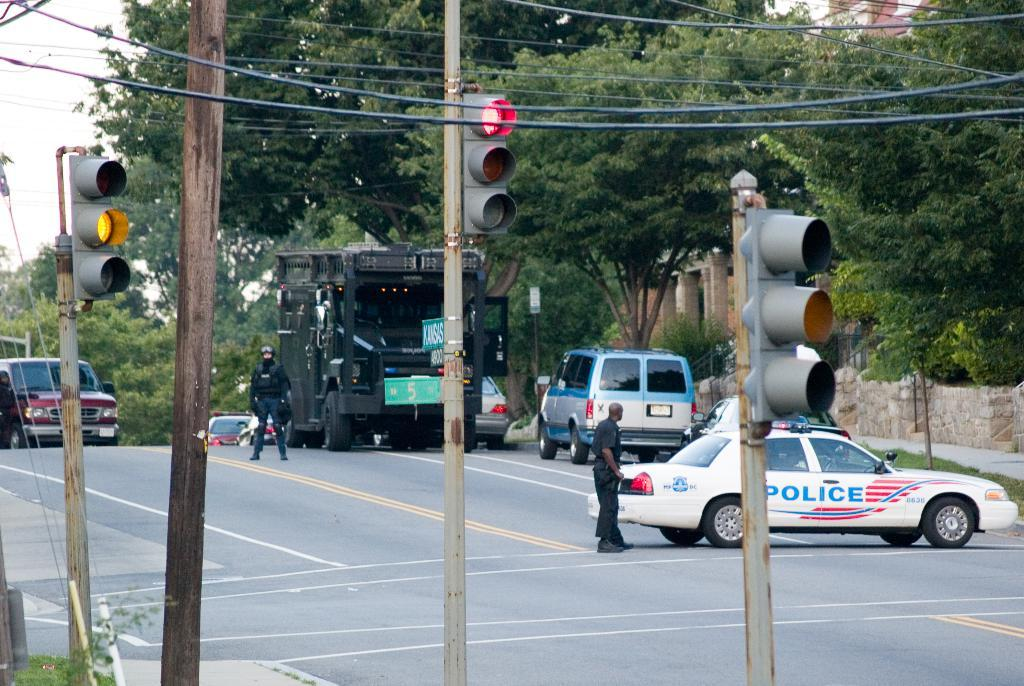<image>
Give a short and clear explanation of the subsequent image. A white, blue and red police car is sitting on the middle of the road. 